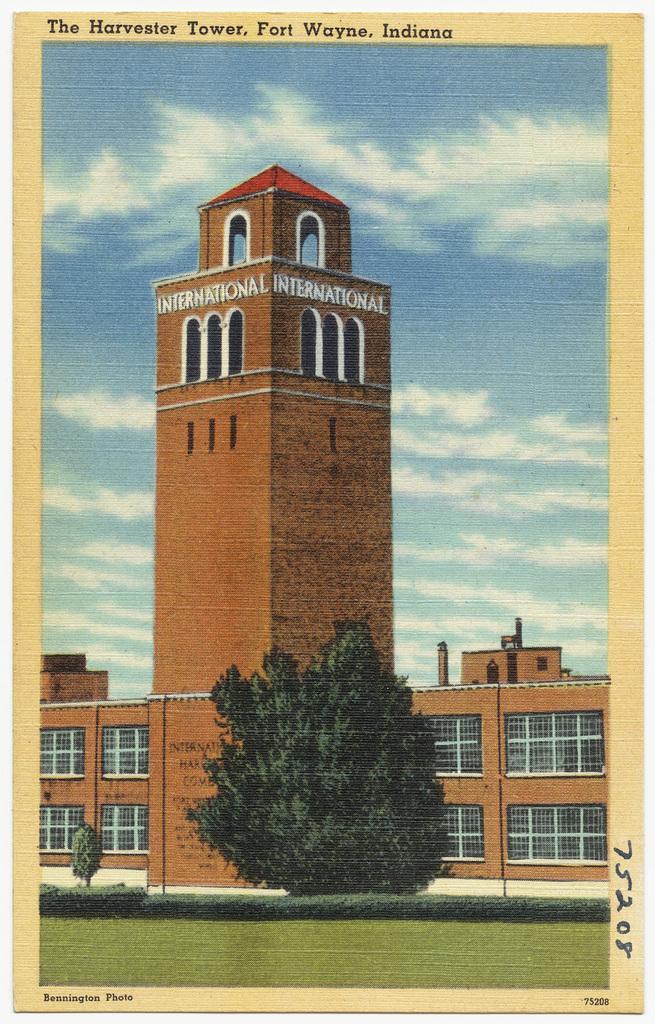Please provide a concise description of this image. I can see that this is a depiction picture and I see the grass in front and in the background I see the building and I see the trees and I see the sky and on the top and right bottom and left bottom of this image I see something is written. 